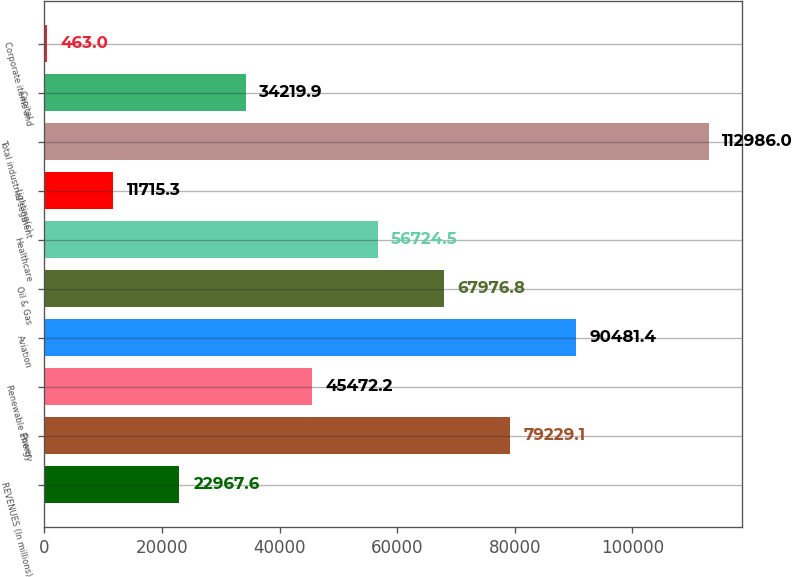Convert chart to OTSL. <chart><loc_0><loc_0><loc_500><loc_500><bar_chart><fcel>REVENUES (In millions)<fcel>Power<fcel>Renewable Energy<fcel>Aviation<fcel>Oil & Gas<fcel>Healthcare<fcel>Lighting(c)<fcel>Total industrial segment<fcel>Capital<fcel>Corporate items and<nl><fcel>22967.6<fcel>79229.1<fcel>45472.2<fcel>90481.4<fcel>67976.8<fcel>56724.5<fcel>11715.3<fcel>112986<fcel>34219.9<fcel>463<nl></chart> 